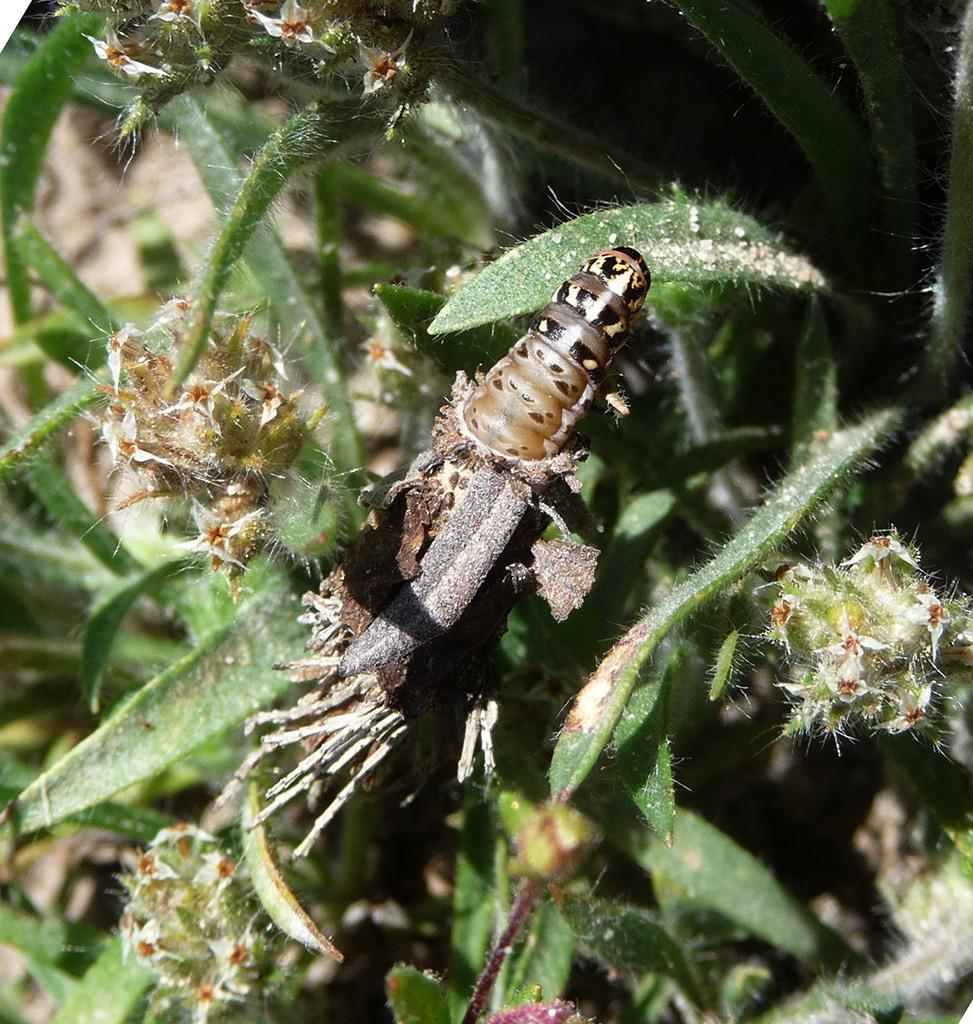What type of creature is present in the image? There is an insect in the image. Where is the insect located? The insect is on a plant. What organization does the insect represent in the image? The insect does not represent any organization in the image. How does the insect move around on the plant in the image? The insect's movement cannot be determined from the image alone, as it is a still photograph. 